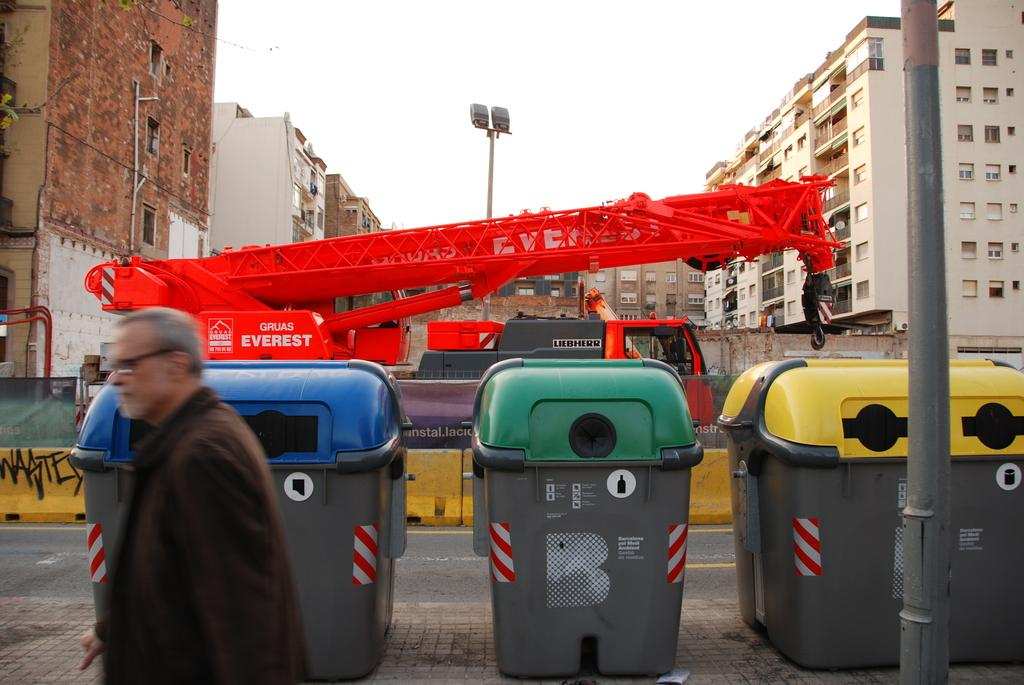<image>
Write a terse but informative summary of the picture. A large, red Everest construction machine is parked in a construction zone. 